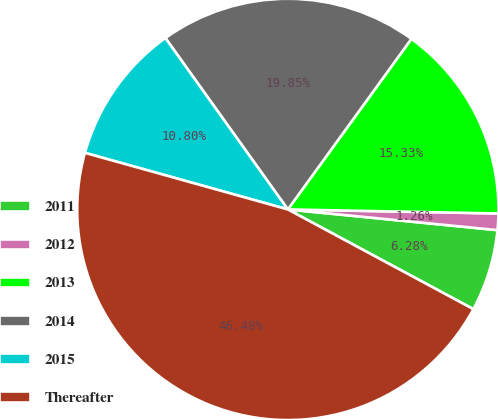Convert chart. <chart><loc_0><loc_0><loc_500><loc_500><pie_chart><fcel>2011<fcel>2012<fcel>2013<fcel>2014<fcel>2015<fcel>Thereafter<nl><fcel>6.28%<fcel>1.26%<fcel>15.33%<fcel>19.85%<fcel>10.8%<fcel>46.48%<nl></chart> 